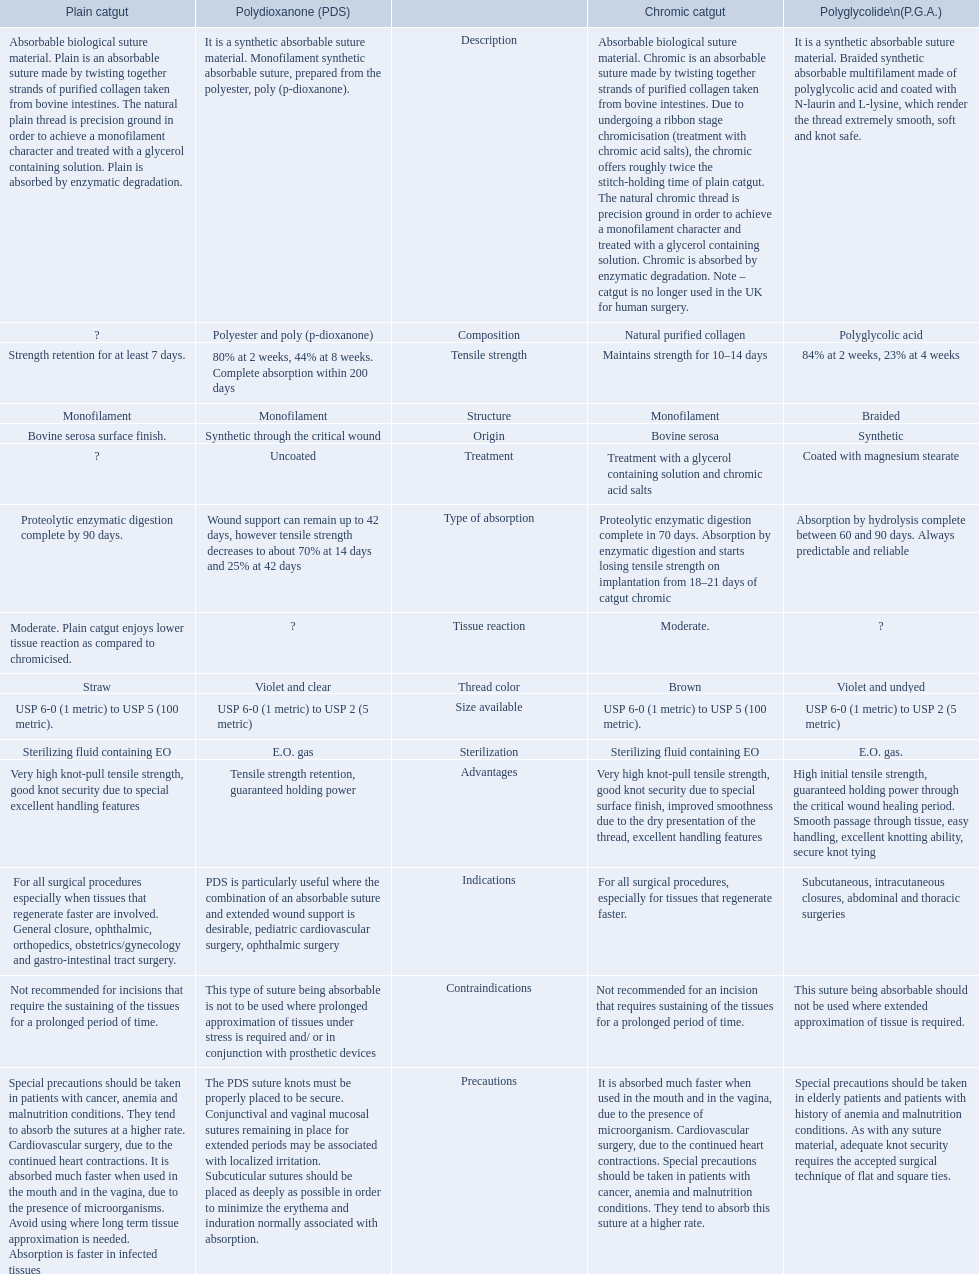How many days does the chronic catgut retain strength? Maintains strength for 10–14 days. What is plain catgut? Absorbable biological suture material. Plain is an absorbable suture made by twisting together strands of purified collagen taken from bovine intestines. The natural plain thread is precision ground in order to achieve a monofilament character and treated with a glycerol containing solution. Plain is absorbed by enzymatic degradation. How many days does catgut retain strength? Strength retention for at least 7 days. 